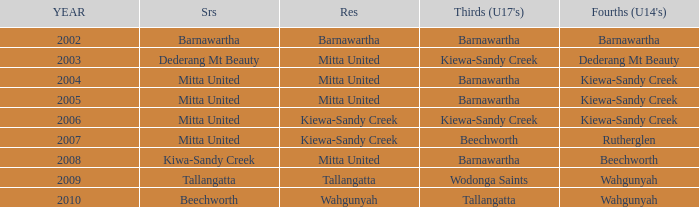Which Seniors have YEAR before 2006, and Fourths (Under 14's) of kiewa-sandy creek? Mitta United, Mitta United. 